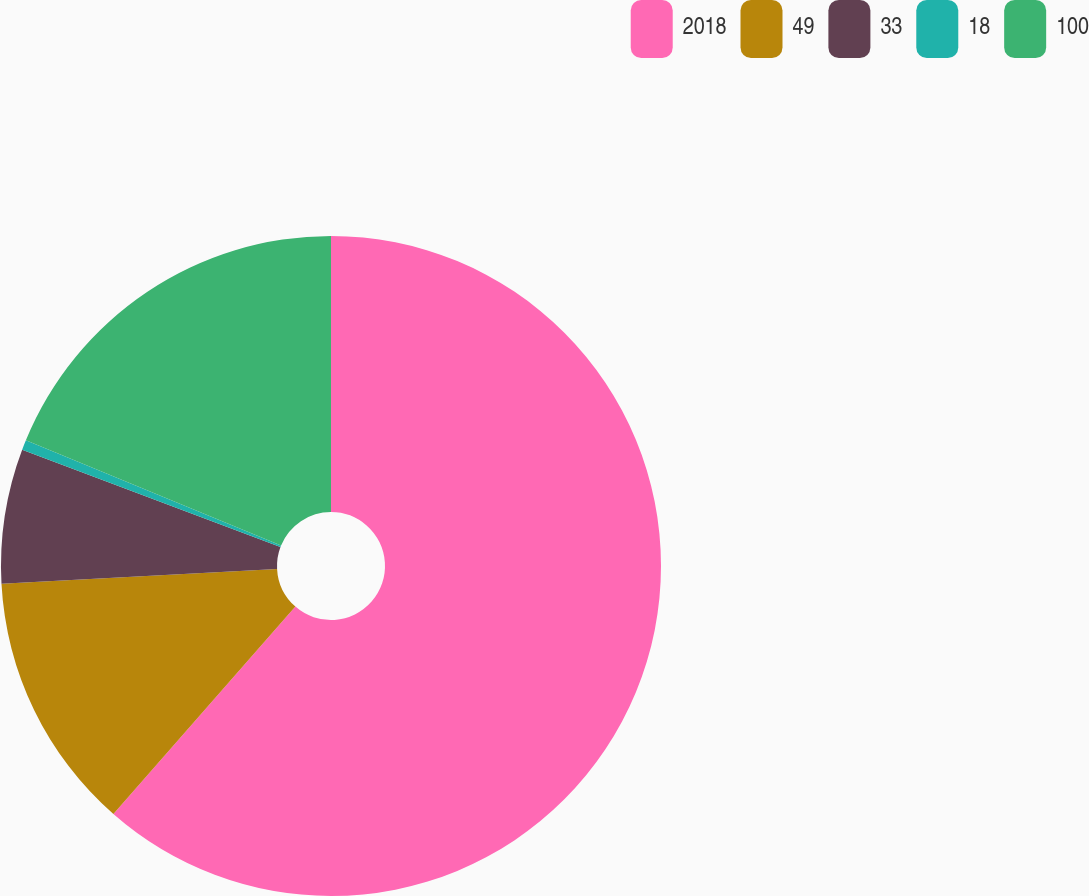<chart> <loc_0><loc_0><loc_500><loc_500><pie_chart><fcel>2018<fcel>49<fcel>33<fcel>18<fcel>100<nl><fcel>61.46%<fcel>12.68%<fcel>6.59%<fcel>0.49%<fcel>18.78%<nl></chart> 